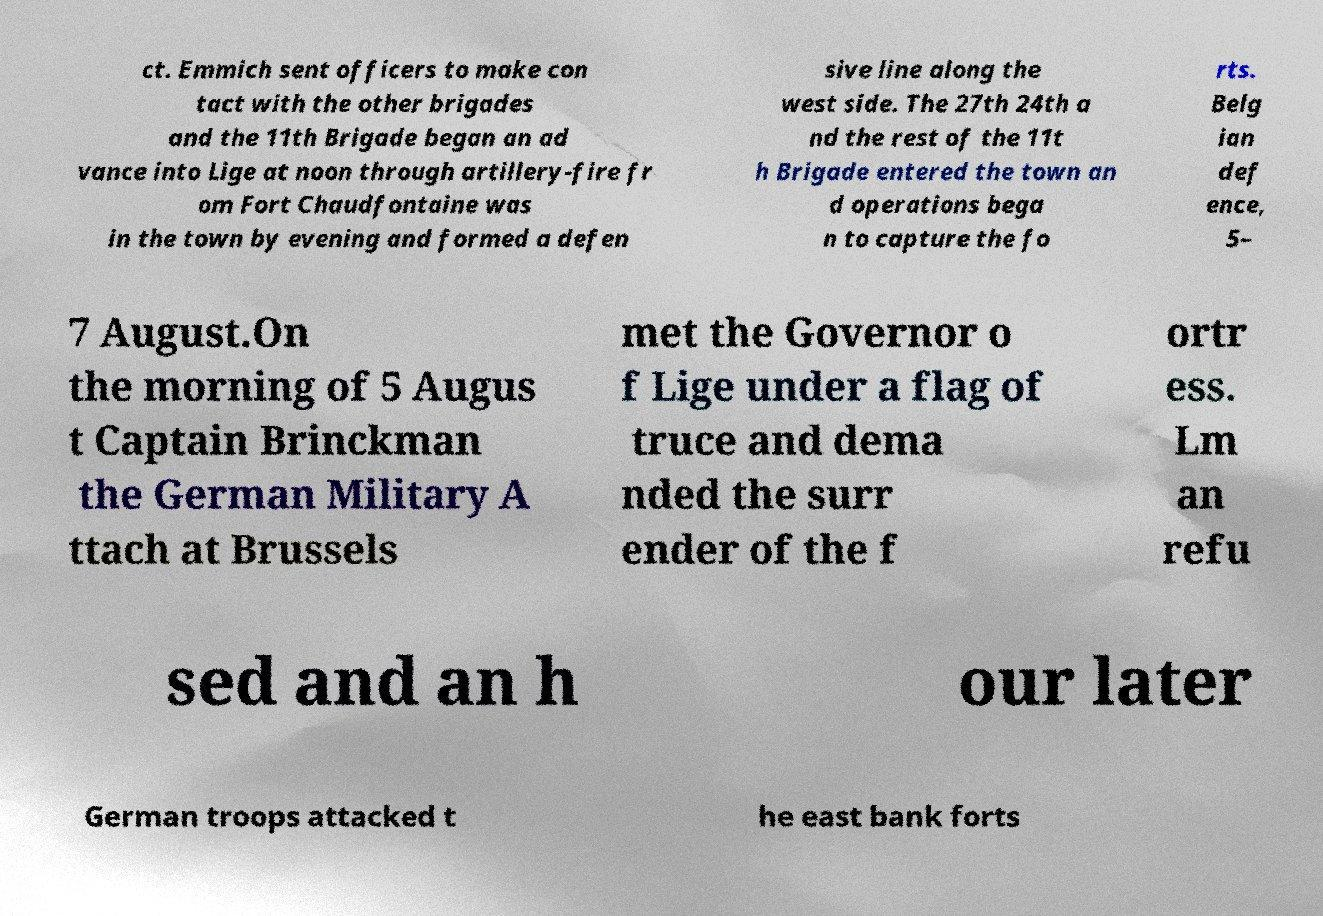Can you read and provide the text displayed in the image?This photo seems to have some interesting text. Can you extract and type it out for me? ct. Emmich sent officers to make con tact with the other brigades and the 11th Brigade began an ad vance into Lige at noon through artillery-fire fr om Fort Chaudfontaine was in the town by evening and formed a defen sive line along the west side. The 27th 24th a nd the rest of the 11t h Brigade entered the town an d operations bega n to capture the fo rts. Belg ian def ence, 5– 7 August.On the morning of 5 Augus t Captain Brinckman the German Military A ttach at Brussels met the Governor o f Lige under a flag of truce and dema nded the surr ender of the f ortr ess. Lm an refu sed and an h our later German troops attacked t he east bank forts 